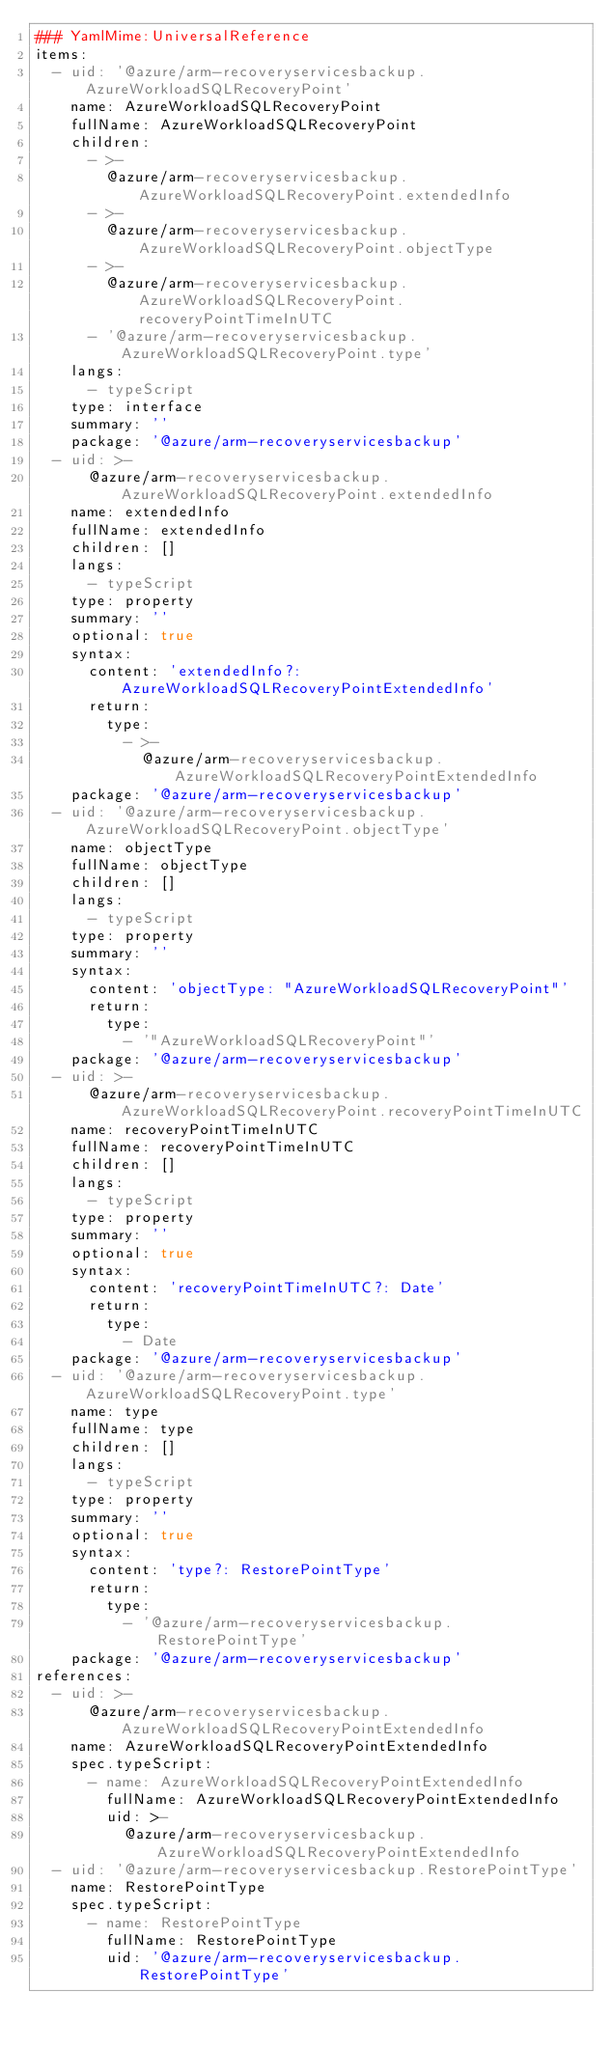Convert code to text. <code><loc_0><loc_0><loc_500><loc_500><_YAML_>### YamlMime:UniversalReference
items:
  - uid: '@azure/arm-recoveryservicesbackup.AzureWorkloadSQLRecoveryPoint'
    name: AzureWorkloadSQLRecoveryPoint
    fullName: AzureWorkloadSQLRecoveryPoint
    children:
      - >-
        @azure/arm-recoveryservicesbackup.AzureWorkloadSQLRecoveryPoint.extendedInfo
      - >-
        @azure/arm-recoveryservicesbackup.AzureWorkloadSQLRecoveryPoint.objectType
      - >-
        @azure/arm-recoveryservicesbackup.AzureWorkloadSQLRecoveryPoint.recoveryPointTimeInUTC
      - '@azure/arm-recoveryservicesbackup.AzureWorkloadSQLRecoveryPoint.type'
    langs:
      - typeScript
    type: interface
    summary: ''
    package: '@azure/arm-recoveryservicesbackup'
  - uid: >-
      @azure/arm-recoveryservicesbackup.AzureWorkloadSQLRecoveryPoint.extendedInfo
    name: extendedInfo
    fullName: extendedInfo
    children: []
    langs:
      - typeScript
    type: property
    summary: ''
    optional: true
    syntax:
      content: 'extendedInfo?: AzureWorkloadSQLRecoveryPointExtendedInfo'
      return:
        type:
          - >-
            @azure/arm-recoveryservicesbackup.AzureWorkloadSQLRecoveryPointExtendedInfo
    package: '@azure/arm-recoveryservicesbackup'
  - uid: '@azure/arm-recoveryservicesbackup.AzureWorkloadSQLRecoveryPoint.objectType'
    name: objectType
    fullName: objectType
    children: []
    langs:
      - typeScript
    type: property
    summary: ''
    syntax:
      content: 'objectType: "AzureWorkloadSQLRecoveryPoint"'
      return:
        type:
          - '"AzureWorkloadSQLRecoveryPoint"'
    package: '@azure/arm-recoveryservicesbackup'
  - uid: >-
      @azure/arm-recoveryservicesbackup.AzureWorkloadSQLRecoveryPoint.recoveryPointTimeInUTC
    name: recoveryPointTimeInUTC
    fullName: recoveryPointTimeInUTC
    children: []
    langs:
      - typeScript
    type: property
    summary: ''
    optional: true
    syntax:
      content: 'recoveryPointTimeInUTC?: Date'
      return:
        type:
          - Date
    package: '@azure/arm-recoveryservicesbackup'
  - uid: '@azure/arm-recoveryservicesbackup.AzureWorkloadSQLRecoveryPoint.type'
    name: type
    fullName: type
    children: []
    langs:
      - typeScript
    type: property
    summary: ''
    optional: true
    syntax:
      content: 'type?: RestorePointType'
      return:
        type:
          - '@azure/arm-recoveryservicesbackup.RestorePointType'
    package: '@azure/arm-recoveryservicesbackup'
references:
  - uid: >-
      @azure/arm-recoveryservicesbackup.AzureWorkloadSQLRecoveryPointExtendedInfo
    name: AzureWorkloadSQLRecoveryPointExtendedInfo
    spec.typeScript:
      - name: AzureWorkloadSQLRecoveryPointExtendedInfo
        fullName: AzureWorkloadSQLRecoveryPointExtendedInfo
        uid: >-
          @azure/arm-recoveryservicesbackup.AzureWorkloadSQLRecoveryPointExtendedInfo
  - uid: '@azure/arm-recoveryservicesbackup.RestorePointType'
    name: RestorePointType
    spec.typeScript:
      - name: RestorePointType
        fullName: RestorePointType
        uid: '@azure/arm-recoveryservicesbackup.RestorePointType'
</code> 